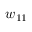Convert formula to latex. <formula><loc_0><loc_0><loc_500><loc_500>w _ { 1 1 }</formula> 